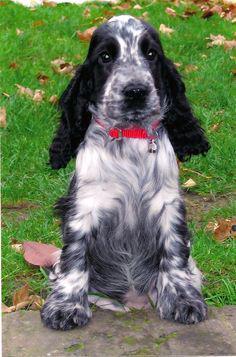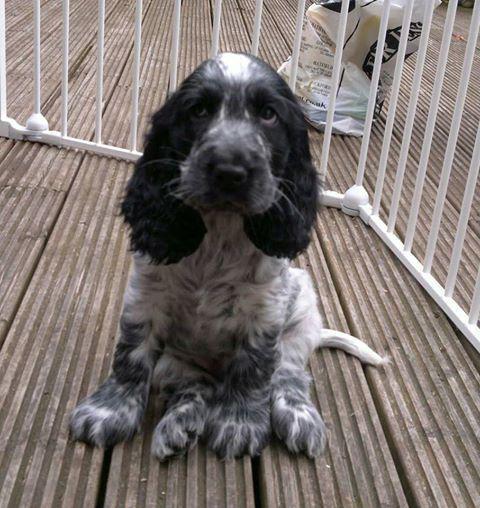The first image is the image on the left, the second image is the image on the right. For the images shown, is this caption "In one image, a small black and gray dog is being held outdoors with its front paws draped over a hand, while a similar dog in a second image is sitting outdoors." true? Answer yes or no. No. The first image is the image on the left, the second image is the image on the right. Given the left and right images, does the statement "A floppy eared dog is in contact with a stick-like object in one image." hold true? Answer yes or no. No. 